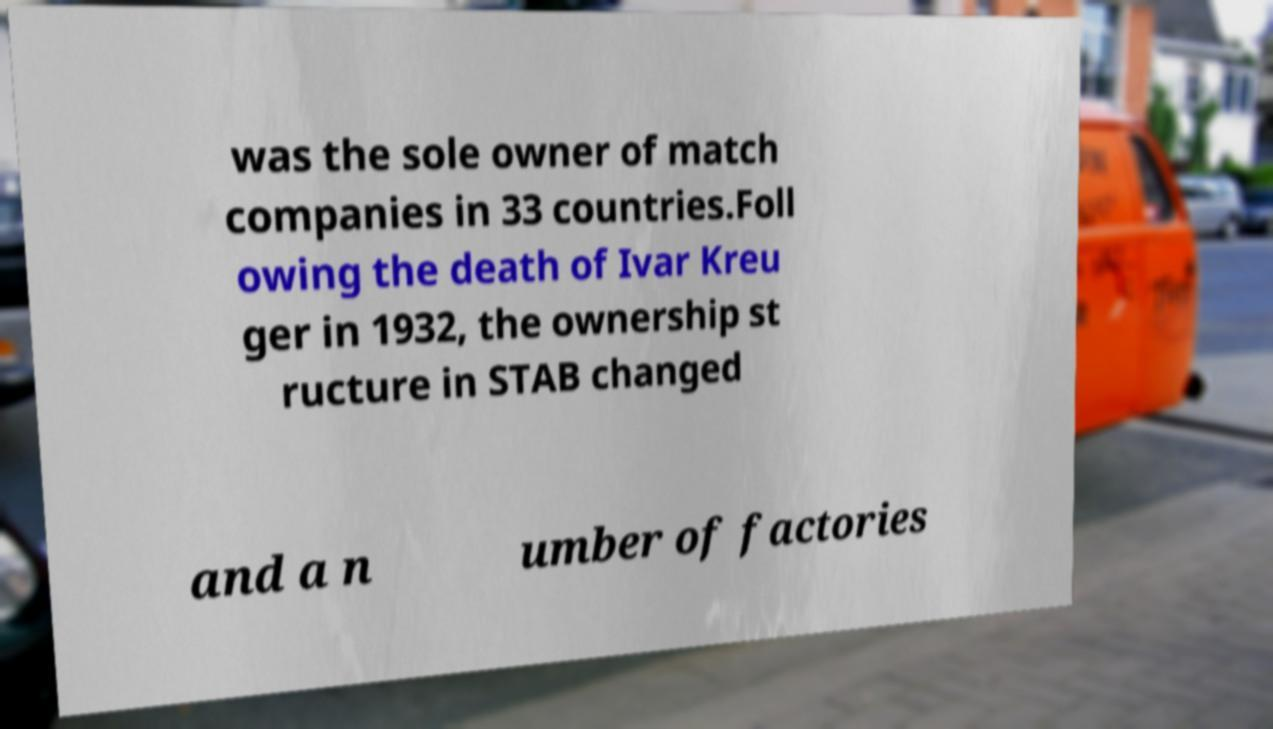I need the written content from this picture converted into text. Can you do that? was the sole owner of match companies in 33 countries.Foll owing the death of Ivar Kreu ger in 1932, the ownership st ructure in STAB changed and a n umber of factories 